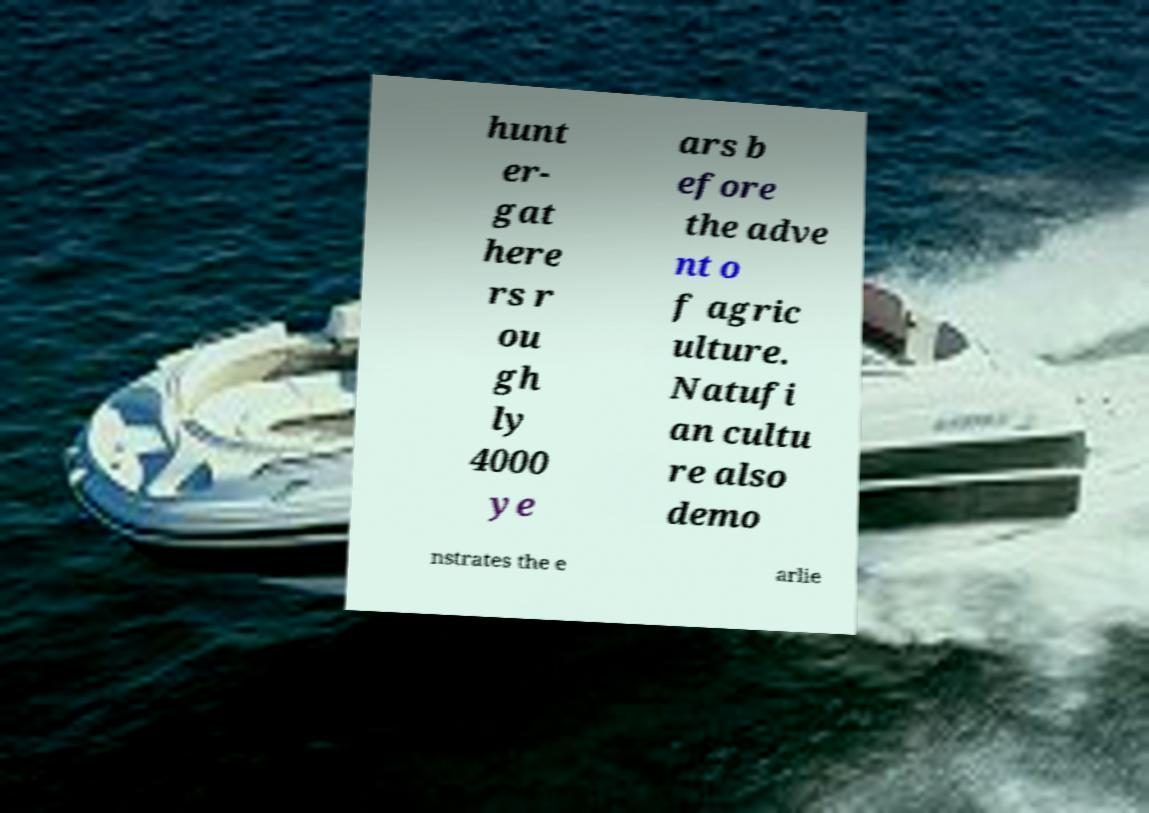Could you assist in decoding the text presented in this image and type it out clearly? hunt er- gat here rs r ou gh ly 4000 ye ars b efore the adve nt o f agric ulture. Natufi an cultu re also demo nstrates the e arlie 